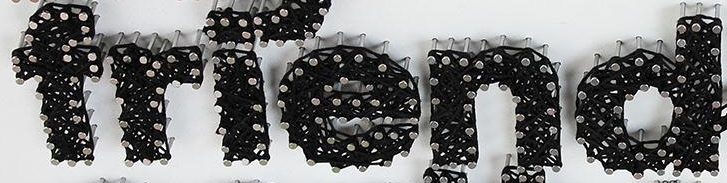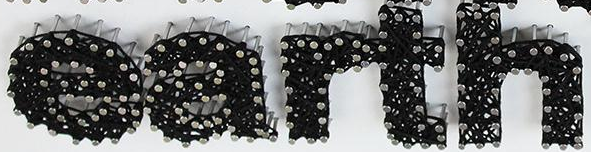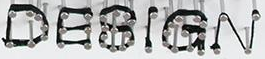What words are shown in these images in order, separated by a semicolon? friend; earth; DESIGN 